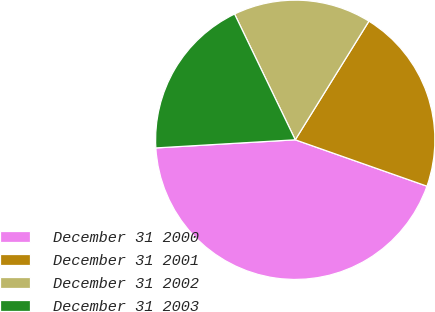Convert chart. <chart><loc_0><loc_0><loc_500><loc_500><pie_chart><fcel>December 31 2000<fcel>December 31 2001<fcel>December 31 2002<fcel>December 31 2003<nl><fcel>43.68%<fcel>21.54%<fcel>16.0%<fcel>18.77%<nl></chart> 